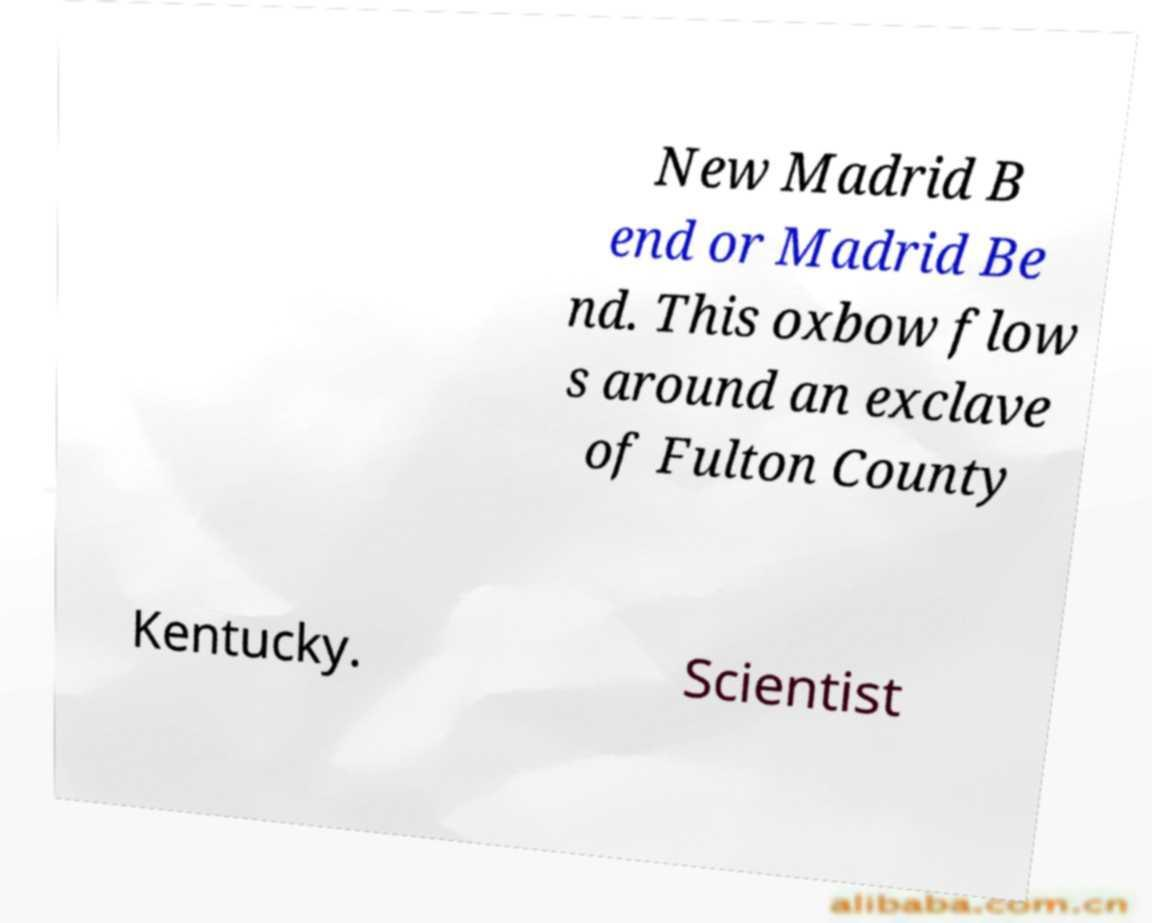Could you extract and type out the text from this image? New Madrid B end or Madrid Be nd. This oxbow flow s around an exclave of Fulton County Kentucky. Scientist 